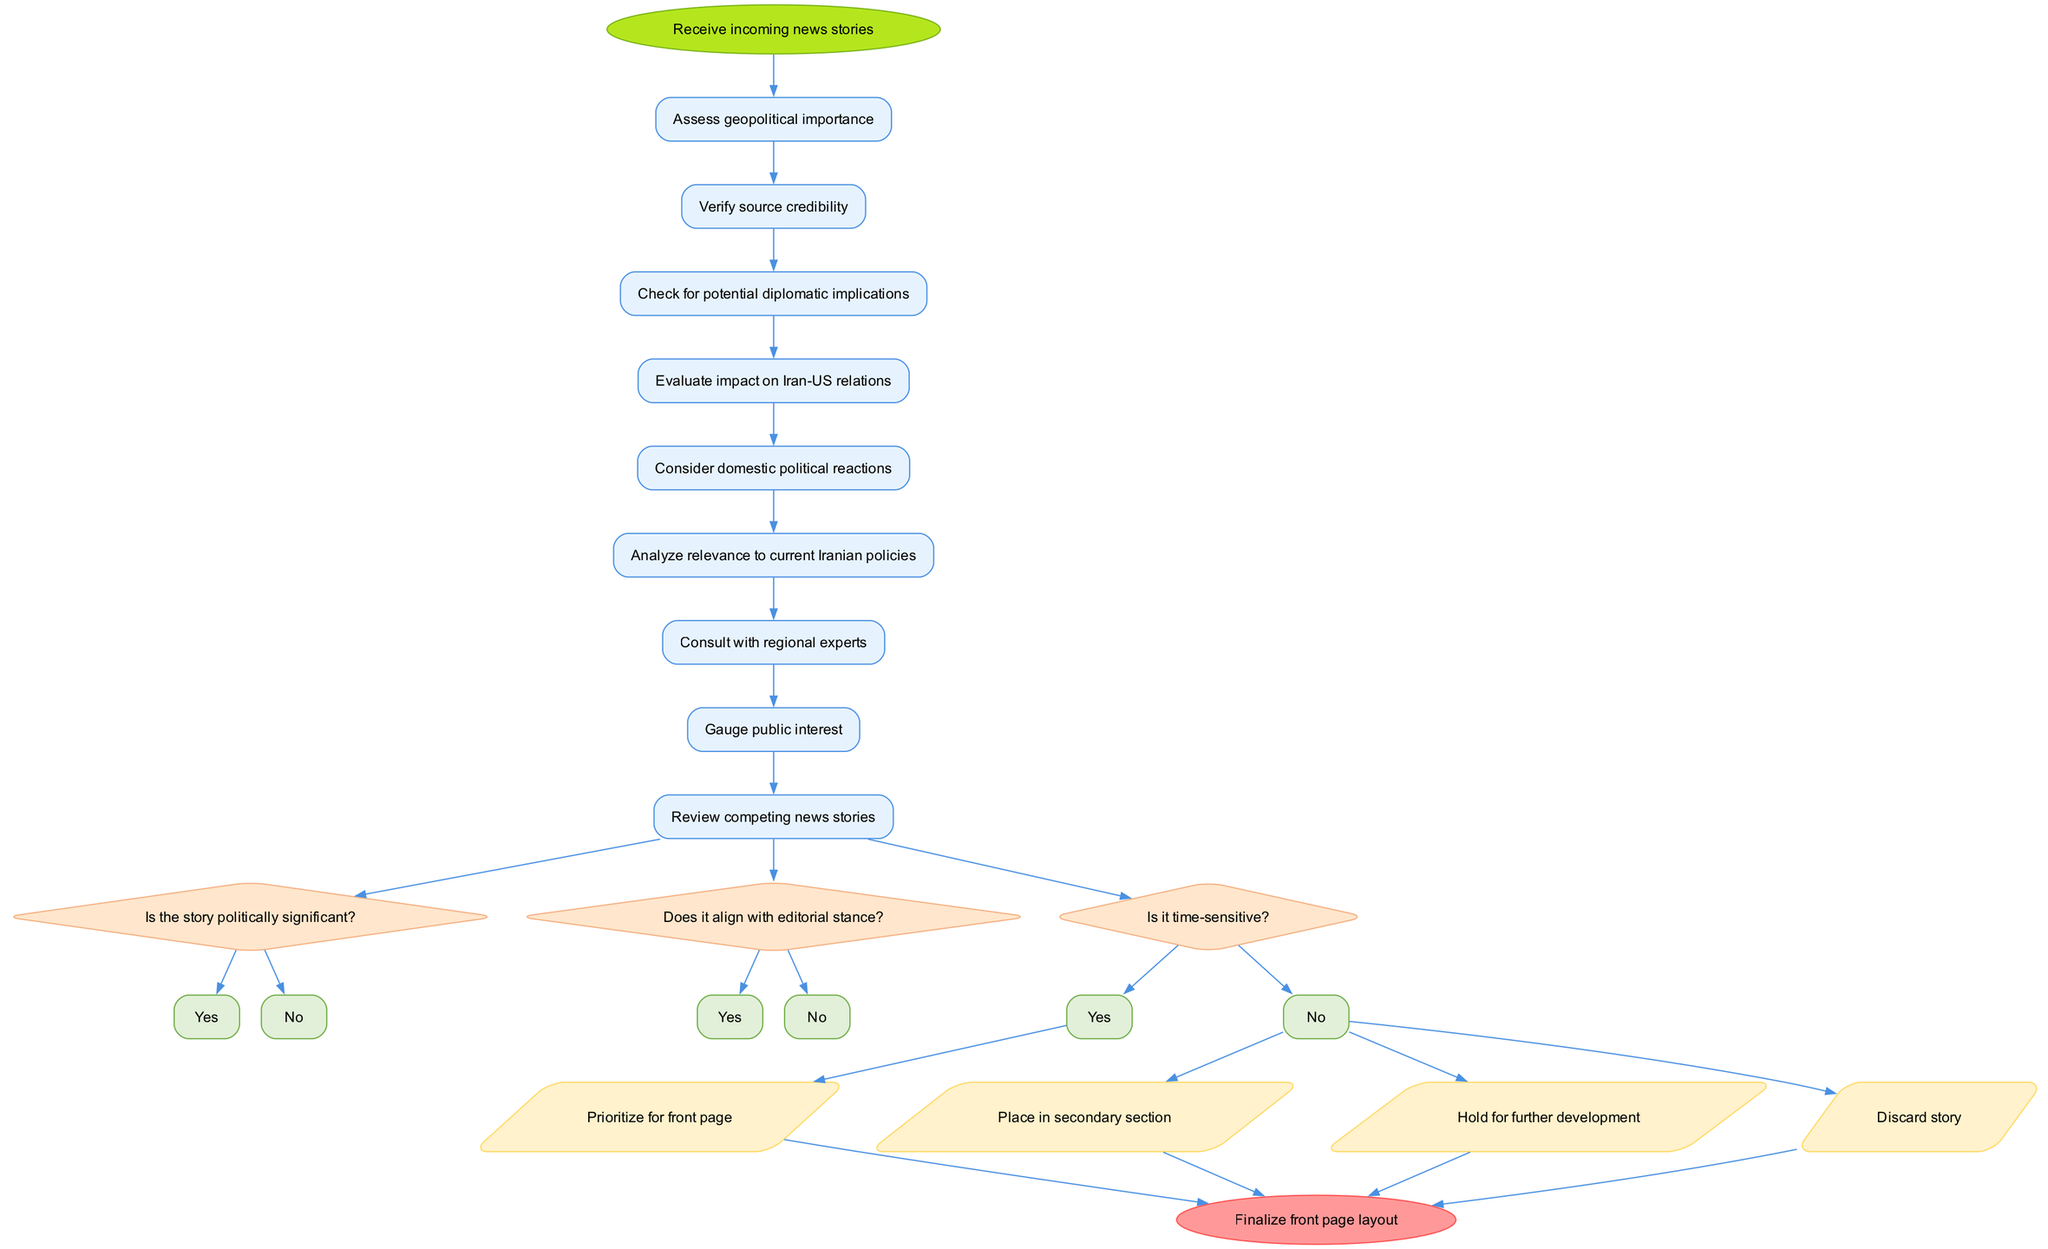What is the starting point of the activity diagram? The starting point, or the start node, is indicated clearly in the diagram, which is "Receive incoming news stories."
Answer: Receive incoming news stories How many activities are listed in the diagram? The diagram contains a total of 9 distinct activities that are part of the decision-making process.
Answer: 9 Which decision follows the last activity? The last activity leads to the decision "Is it time-sensitive?" as it is the final decision noted in the flow of the diagram.
Answer: Is it time-sensitive? What is the action corresponding to a "Yes" response for the question "Is the story politically significant?" The diagram shows that a "Yes" leads to the action "Prioritize for front page," indicating immediate importance.
Answer: Prioritize for front page If a story is time-sensitive and politically significant, what is the resulting action? The flow from both "Is the story politically significant?" and "Is it time-sensitive?" shows that if both decisions lead to a "Yes," the resulting action is "Prioritize for front page."
Answer: Prioritize for front page What is the final step after all actions are completed? The final step in the process, indicated by the end node, is to "Finalize front page layout," which concludes the decision-making flow.
Answer: Finalize front page layout How many total decisions are presented in the diagram? The diagram presents a total of 3 decisions to evaluate the news stories for prioritization.
Answer: 3 What happens if a story is discarded? In the case that a story is discarded, it will not be prioritized or developed further, as shown in the flow leading to disposal of that story.
Answer: Discard story What actions are available after the last decision? Following the last decision, the possible actions available are "Prioritize for front page," "Place in secondary section," "Hold for further development," or "Discard story."
Answer: Prioritize for front page, Place in secondary section, Hold for further development, Discard story 